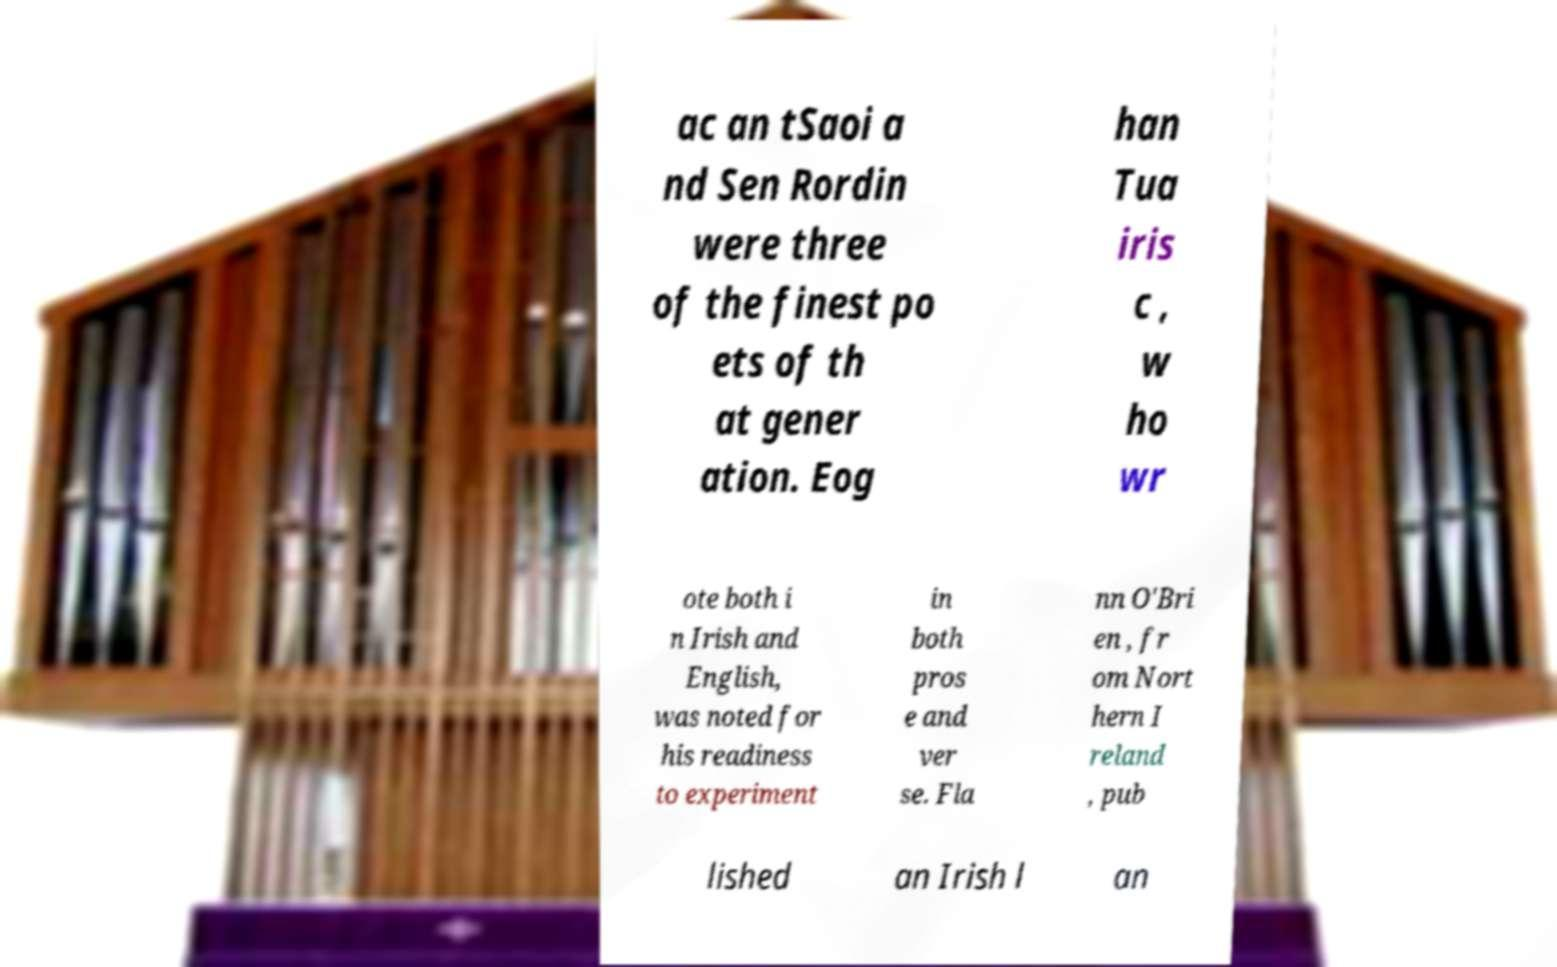Can you read and provide the text displayed in the image?This photo seems to have some interesting text. Can you extract and type it out for me? ac an tSaoi a nd Sen Rordin were three of the finest po ets of th at gener ation. Eog han Tua iris c , w ho wr ote both i n Irish and English, was noted for his readiness to experiment in both pros e and ver se. Fla nn O'Bri en , fr om Nort hern I reland , pub lished an Irish l an 